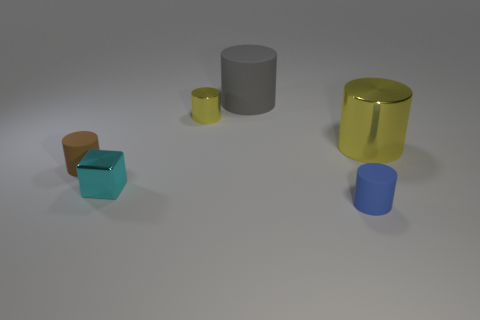Which object appears to be closest to the camera? The cyan cube appears to be the closest to the camera. It's positioned in the foreground of the image, making it appear more prominent compared to the other objects. Can you tell me if this cube is also the smallest object in the image? Indeed, the cyan cube is not only the closest to the camera but it also appears to be the smallest object in the scene in terms of its dimensions. 